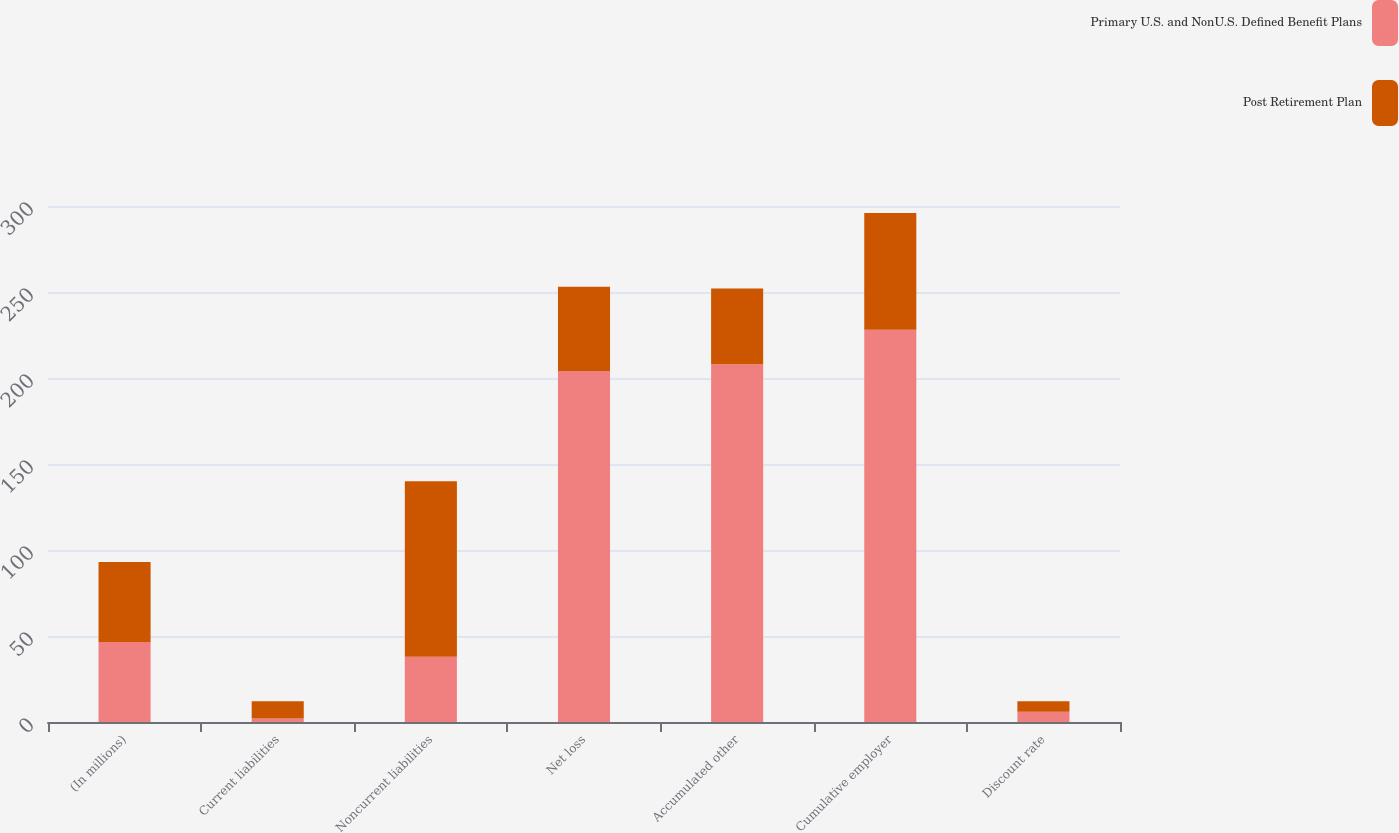Convert chart. <chart><loc_0><loc_0><loc_500><loc_500><stacked_bar_chart><ecel><fcel>(In millions)<fcel>Current liabilities<fcel>Noncurrent liabilities<fcel>Net loss<fcel>Accumulated other<fcel>Cumulative employer<fcel>Discount rate<nl><fcel>Primary U.S. and NonU.S. Defined Benefit Plans<fcel>46.5<fcel>2<fcel>38<fcel>204<fcel>208<fcel>228<fcel>6<nl><fcel>Post Retirement Plan<fcel>46.5<fcel>10<fcel>102<fcel>49<fcel>44<fcel>68<fcel>6<nl></chart> 